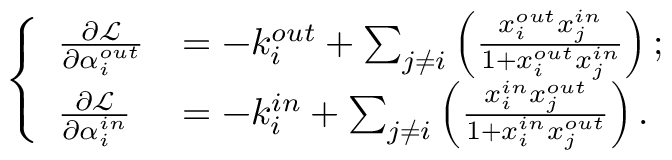Convert formula to latex. <formula><loc_0><loc_0><loc_500><loc_500>\left \{ \begin{array} { l l } { \frac { \partial \mathcal { L } } { \partial \alpha _ { i } ^ { o u t } } } & { = - k _ { i } ^ { o u t } + \sum _ { j \neq i } \left ( \frac { x _ { i } ^ { o u t } x _ { j } ^ { i n } } { 1 + x _ { i } ^ { o u t } x _ { j } ^ { i n } } \right ) ; } \\ { \frac { \partial \mathcal { L } } { \partial \alpha _ { i } ^ { i n } } } & { = - k _ { i } ^ { i n } + \sum _ { j \neq i } \left ( \frac { x _ { i } ^ { i n } x _ { j } ^ { o u t } } { 1 + x _ { i } ^ { i n } x _ { j } ^ { o u t } } \right ) . } \end{array}</formula> 